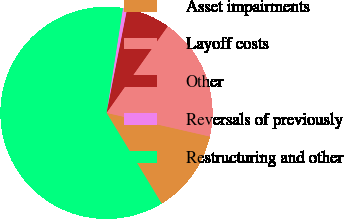Convert chart to OTSL. <chart><loc_0><loc_0><loc_500><loc_500><pie_chart><fcel>Asset impairments<fcel>Layoff costs<fcel>Other<fcel>Reversals of previously<fcel>Restructuring and other<nl><fcel>12.73%<fcel>18.79%<fcel>6.68%<fcel>0.63%<fcel>61.17%<nl></chart> 